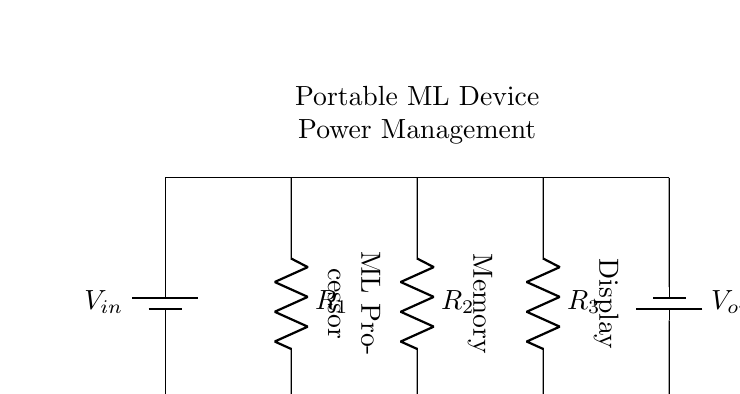What is the type of this circuit? This circuit is a parallel circuit because it consists of multiple resistors (R1, R2, R3) connected across the same two nodes with their terminals connected to the same voltage supply.
Answer: Parallel What does the battery supply in this circuit? The battery supplies voltage, indicated as V_in at the top of the circuit. It provides the necessary potential difference for current to flow through the resistors and power the components.
Answer: Voltage How many resistors are in the circuit? There are three resistors (R1, R2, and R3) connected in parallel within the circuit, identified by their respective labels in the diagram.
Answer: Three What is connected to the output of the circuit? The output of the circuit, labeled V_out, is connected to the load components including the ML Processor, Memory, and Display, which are all powered by the output voltage.
Answer: ML Processor, Memory, Display What is the purpose of the parallel circuit configuration here? The purpose of the parallel circuit configuration is to allow multiple devices (the ML Processor, Memory, and Display) to operate simultaneously, ensuring they all receive the same voltage while allowing for independent current paths.
Answer: Simultaneous operation Which components can the output voltage power? The output voltage can power the ML Processor, Memory, and Display, as all three components are directly joined to V_out in the circuit diagram.
Answer: ML Processor, Memory, Display 